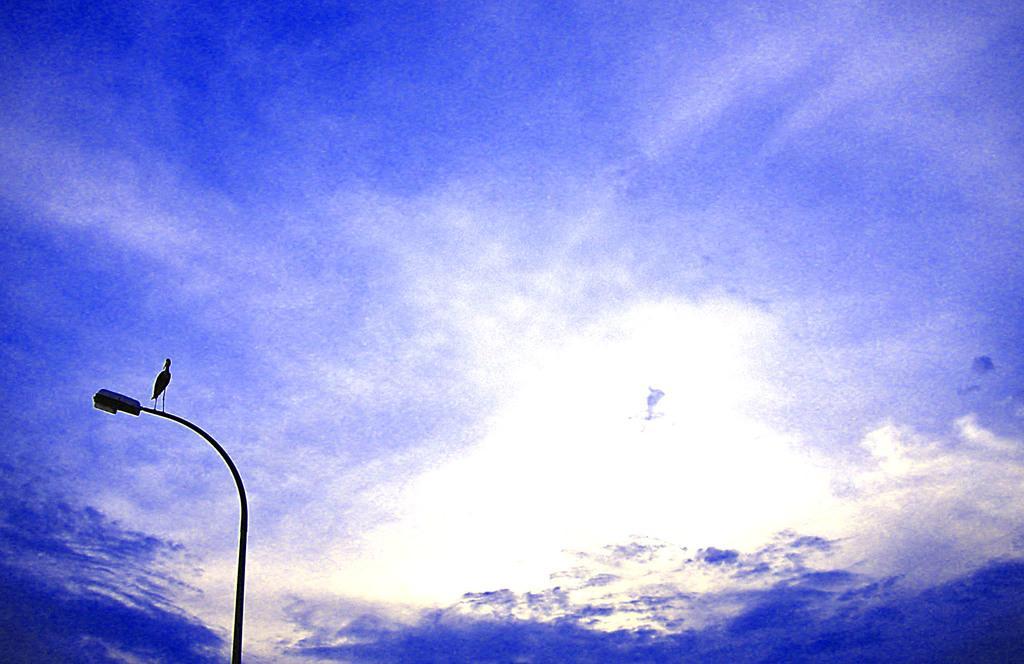Can you describe this image briefly? In this image, we can see a bird on a street light and in the background, there is sky. 